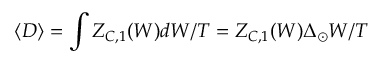Convert formula to latex. <formula><loc_0><loc_0><loc_500><loc_500>\langle D \rangle = \int Z _ { C , 1 } ( W ) d W / T = Z _ { C , 1 } ( W ) \Delta _ { \odot } W / T</formula> 